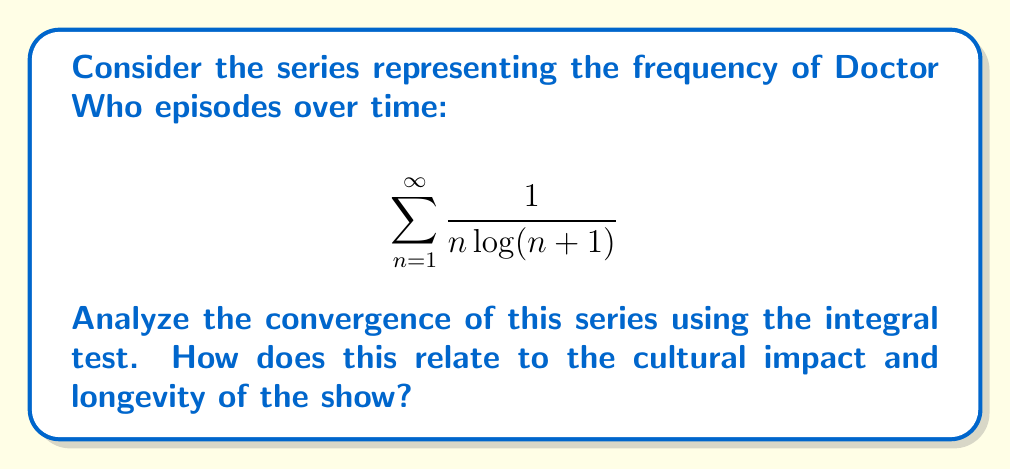What is the answer to this math problem? Let's approach this step-by-step:

1) To use the integral test, we first need to define a function $f(x)$ that matches our series term when $x = n$:

   $$f(x) = \frac{1}{x \log(x+1)}$$

2) The integral test states that if $\int_1^{\infty} f(x) dx$ converges, then the series converges. If the integral diverges, the series diverges.

3) Let's evaluate the integral:

   $$\int_1^{\infty} \frac{1}{x \log(x+1)} dx$$

4) This is a challenging integral. We can solve it using the substitution $u = \log(x+1)$:

   $du = \frac{1}{x+1} dx$
   $x = e^u - 1$

5) Substituting:

   $$\int_{\log 2}^{\infty} \frac{1}{(e^u - 1)u} \cdot (e^u - 1) du = \int_{\log 2}^{\infty} \frac{1}{u} du$$

6) This integral is the definition of the natural logarithm:

   $$[\ln(\ln(x+1))]_1^{\infty} = \lim_{t \to \infty} \ln(\ln(t+1)) - \ln(\ln(2))$$

7) As $t$ approaches infinity, $\ln(\ln(t+1))$ also approaches infinity.

8) Therefore, the integral diverges, which means the original series also diverges.

Relating to Doctor Who:
The divergence of this series suggests that the frequency of episodes, while decreasing over time, doesn't decrease quickly enough for the series to have a finite sum. This could be interpreted as representing the enduring cultural impact of Doctor Who. Despite periods of hiatus, the show continues to produce episodes and maintain cultural relevance, much like how the terms in the series continue to contribute to an ever-growing sum.
Answer: The series $\sum_{n=1}^{\infty} \frac{1}{n \log(n+1)}$ diverges by the integral test. 